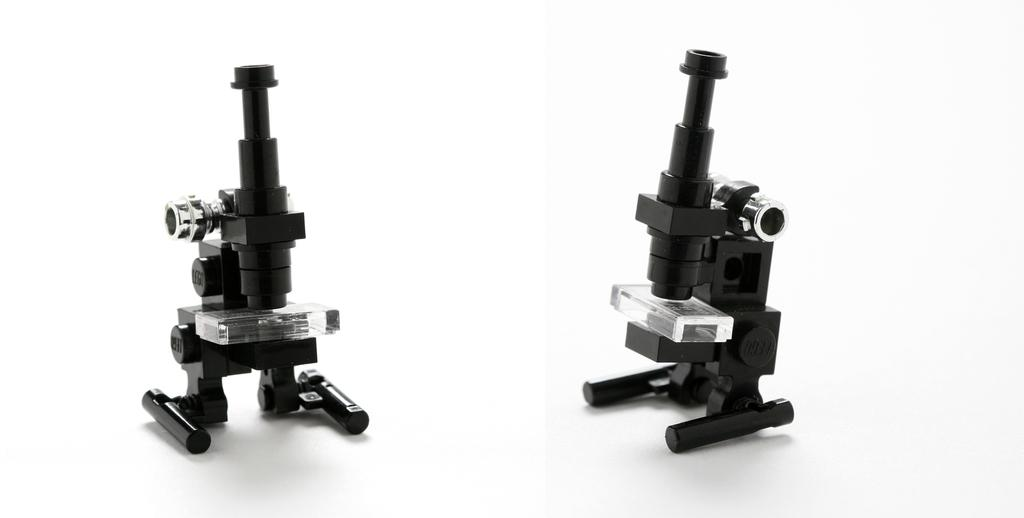What type of equipment is visible in the image? There are microscopes in the image. What color is the background of the image? The background of the image is white. Can you describe the tiger's head in the image? There is no tiger or head present in the image; it features microscopes and a white background. 